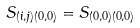Convert formula to latex. <formula><loc_0><loc_0><loc_500><loc_500>S _ { ( i , j ) ( 0 , 0 ) } = S _ { ( 0 , 0 ) ( 0 , 0 ) }</formula> 